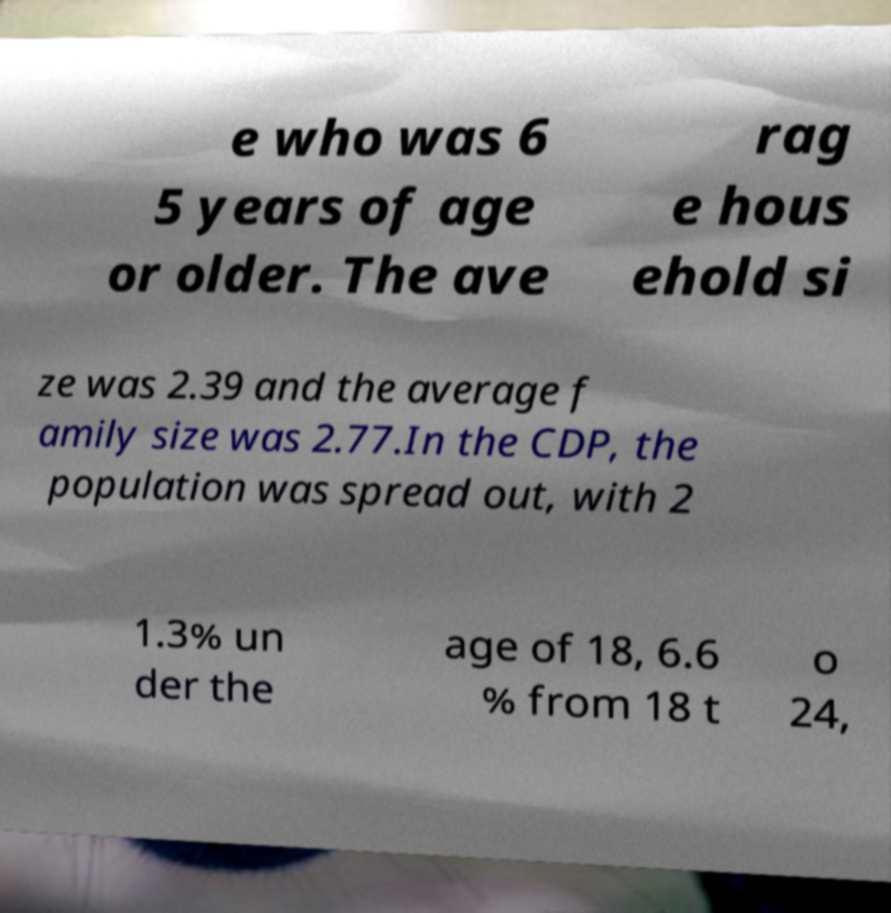What messages or text are displayed in this image? I need them in a readable, typed format. e who was 6 5 years of age or older. The ave rag e hous ehold si ze was 2.39 and the average f amily size was 2.77.In the CDP, the population was spread out, with 2 1.3% un der the age of 18, 6.6 % from 18 t o 24, 